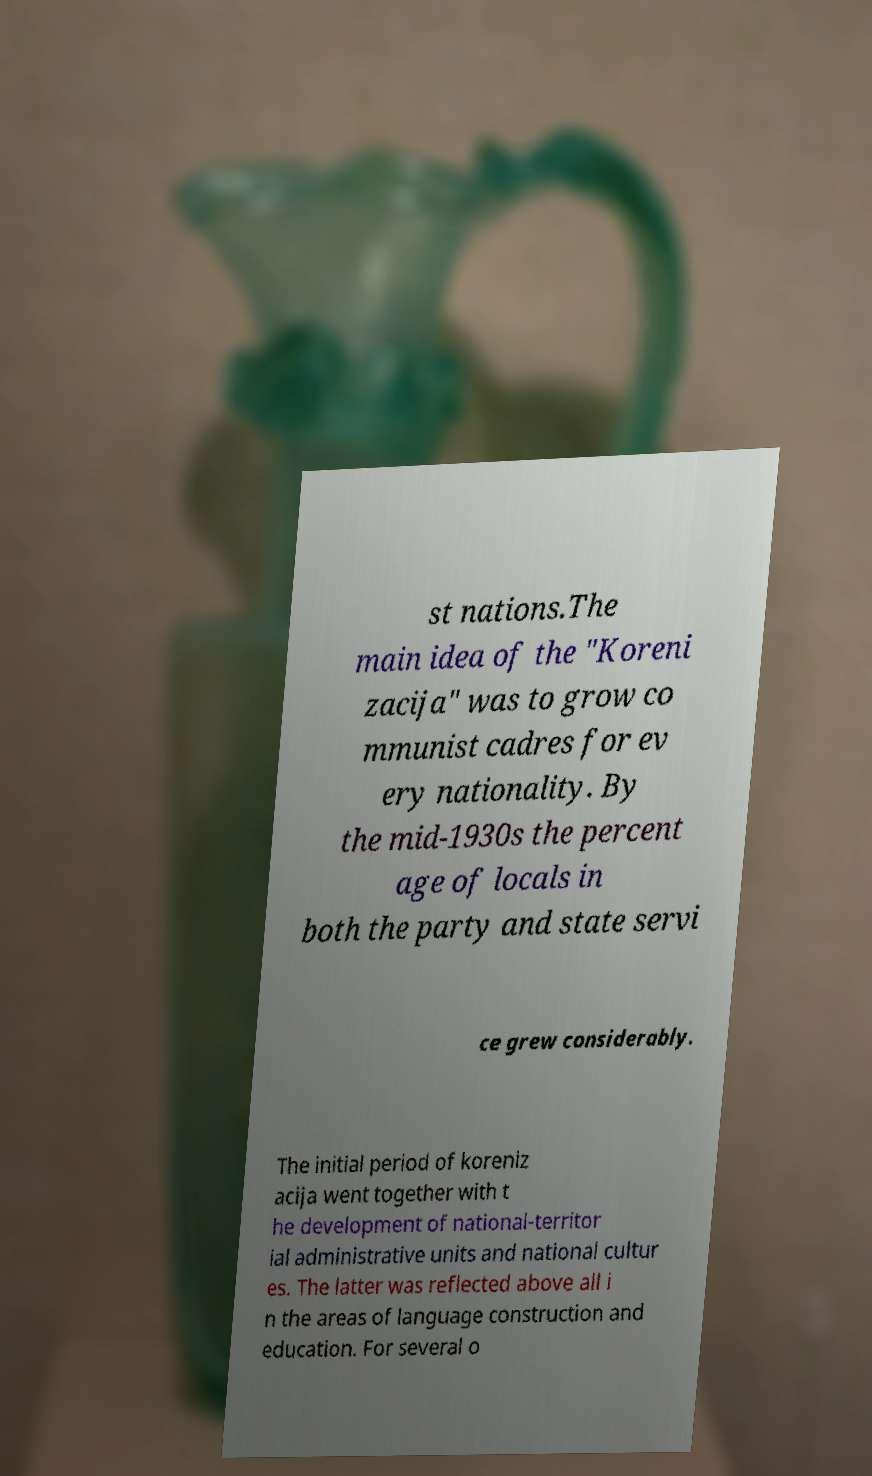What messages or text are displayed in this image? I need them in a readable, typed format. st nations.The main idea of the "Koreni zacija" was to grow co mmunist cadres for ev ery nationality. By the mid-1930s the percent age of locals in both the party and state servi ce grew considerably. The initial period of koreniz acija went together with t he development of national-territor ial administrative units and national cultur es. The latter was reflected above all i n the areas of language construction and education. For several o 